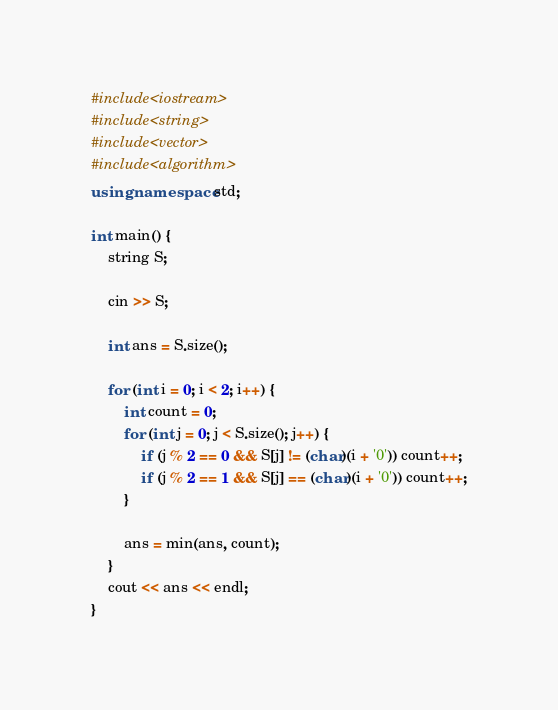Convert code to text. <code><loc_0><loc_0><loc_500><loc_500><_C++_>#include<iostream>
#include<string>
#include<vector>
#include<algorithm>
using namespace std;

int main() {
	string S;

	cin >> S;

	int ans = S.size();

	for (int i = 0; i < 2; i++) {
		int count = 0;
		for (int j = 0; j < S.size(); j++) {
			if (j % 2 == 0 && S[j] != (char)(i + '0')) count++;
			if (j % 2 == 1 && S[j] == (char)(i + '0')) count++;
		}

		ans = min(ans, count);
	}
	cout << ans << endl;
}
</code> 